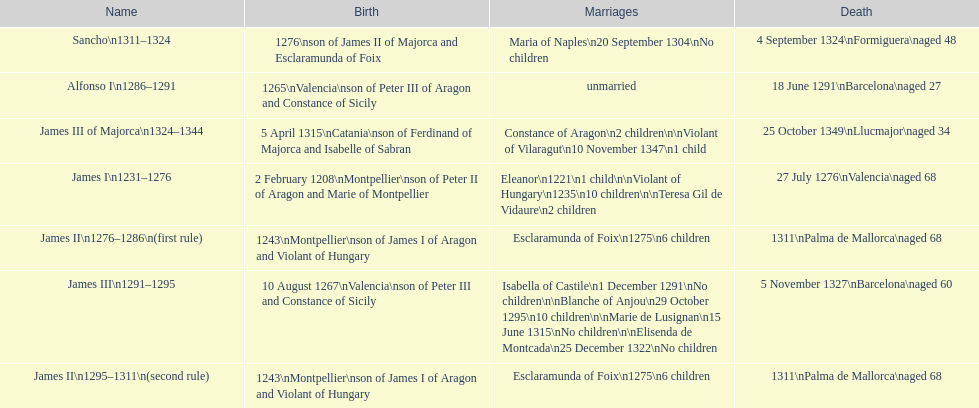Parse the table in full. {'header': ['Name', 'Birth', 'Marriages', 'Death'], 'rows': [['Sancho\\n1311–1324', '1276\\nson of James II of Majorca and Esclaramunda of Foix', 'Maria of Naples\\n20 September 1304\\nNo children', '4 September 1324\\nFormiguera\\naged 48'], ['Alfonso I\\n1286–1291', '1265\\nValencia\\nson of Peter III of Aragon and Constance of Sicily', 'unmarried', '18 June 1291\\nBarcelona\\naged 27'], ['James III of Majorca\\n1324–1344', '5 April 1315\\nCatania\\nson of Ferdinand of Majorca and Isabelle of Sabran', 'Constance of Aragon\\n2 children\\n\\nViolant of Vilaragut\\n10 November 1347\\n1 child', '25 October 1349\\nLlucmajor\\naged 34'], ['James I\\n1231–1276', '2 February 1208\\nMontpellier\\nson of Peter II of Aragon and Marie of Montpellier', 'Eleanor\\n1221\\n1 child\\n\\nViolant of Hungary\\n1235\\n10 children\\n\\nTeresa Gil de Vidaure\\n2 children', '27 July 1276\\nValencia\\naged 68'], ['James II\\n1276–1286\\n(first rule)', '1243\\nMontpellier\\nson of James I of Aragon and Violant of Hungary', 'Esclaramunda of Foix\\n1275\\n6 children', '1311\\nPalma de Mallorca\\naged 68'], ['James III\\n1291–1295', '10 August 1267\\nValencia\\nson of Peter III and Constance of Sicily', 'Isabella of Castile\\n1 December 1291\\nNo children\\n\\nBlanche of Anjou\\n29 October 1295\\n10 children\\n\\nMarie de Lusignan\\n15 June 1315\\nNo children\\n\\nElisenda de Montcada\\n25 December 1322\\nNo children', '5 November 1327\\nBarcelona\\naged 60'], ['James II\\n1295–1311\\n(second rule)', '1243\\nMontpellier\\nson of James I of Aragon and Violant of Hungary', 'Esclaramunda of Foix\\n1275\\n6 children', '1311\\nPalma de Mallorca\\naged 68']]} Which two monarchs had no children? Alfonso I, Sancho. 